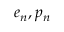<formula> <loc_0><loc_0><loc_500><loc_500>e _ { n } , p _ { n }</formula> 